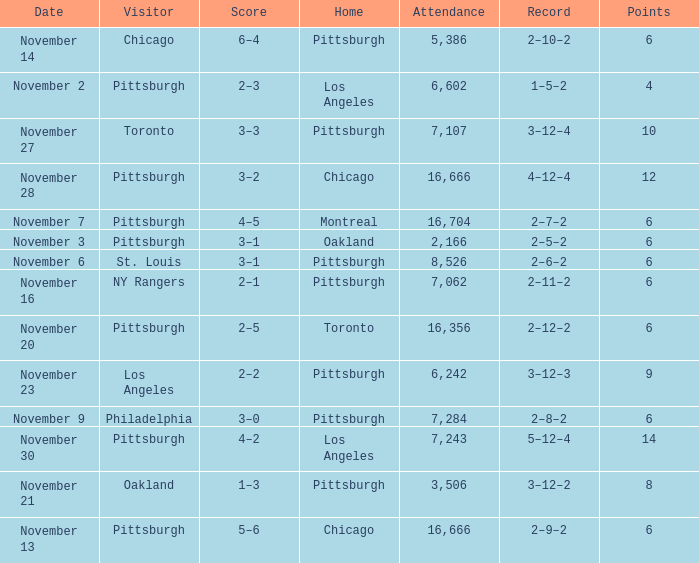What is the sum of the points of the game with philadelphia as the visitor and an attendance greater than 7,284? None. 